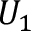<formula> <loc_0><loc_0><loc_500><loc_500>U _ { 1 }</formula> 